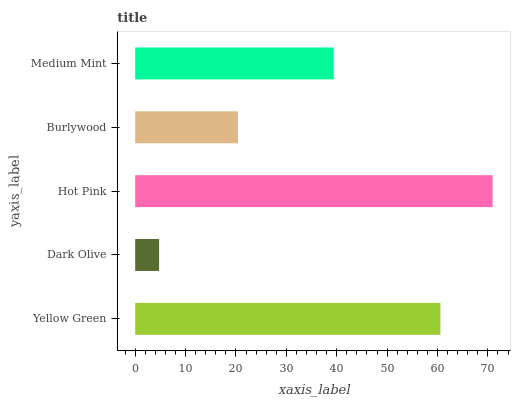Is Dark Olive the minimum?
Answer yes or no. Yes. Is Hot Pink the maximum?
Answer yes or no. Yes. Is Hot Pink the minimum?
Answer yes or no. No. Is Dark Olive the maximum?
Answer yes or no. No. Is Hot Pink greater than Dark Olive?
Answer yes or no. Yes. Is Dark Olive less than Hot Pink?
Answer yes or no. Yes. Is Dark Olive greater than Hot Pink?
Answer yes or no. No. Is Hot Pink less than Dark Olive?
Answer yes or no. No. Is Medium Mint the high median?
Answer yes or no. Yes. Is Medium Mint the low median?
Answer yes or no. Yes. Is Burlywood the high median?
Answer yes or no. No. Is Yellow Green the low median?
Answer yes or no. No. 